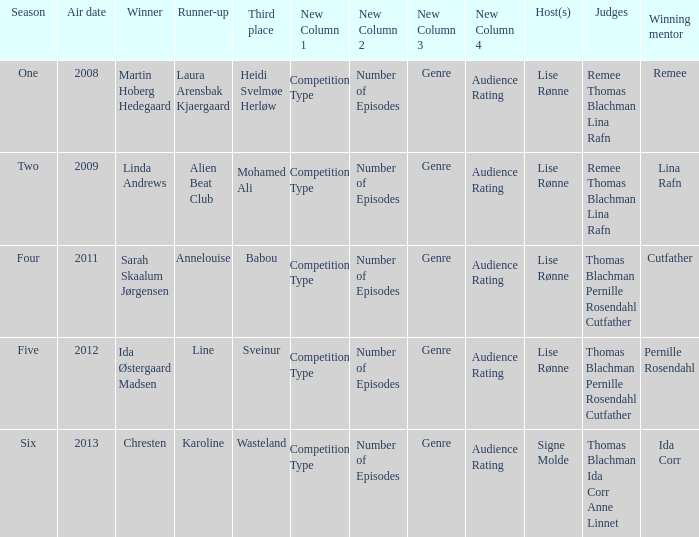Who was the runner-up when Mohamed Ali got third? Alien Beat Club. 